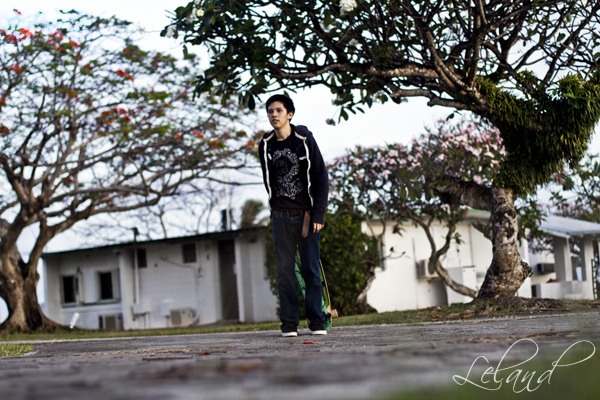Read and extract the text from this image. Leland 